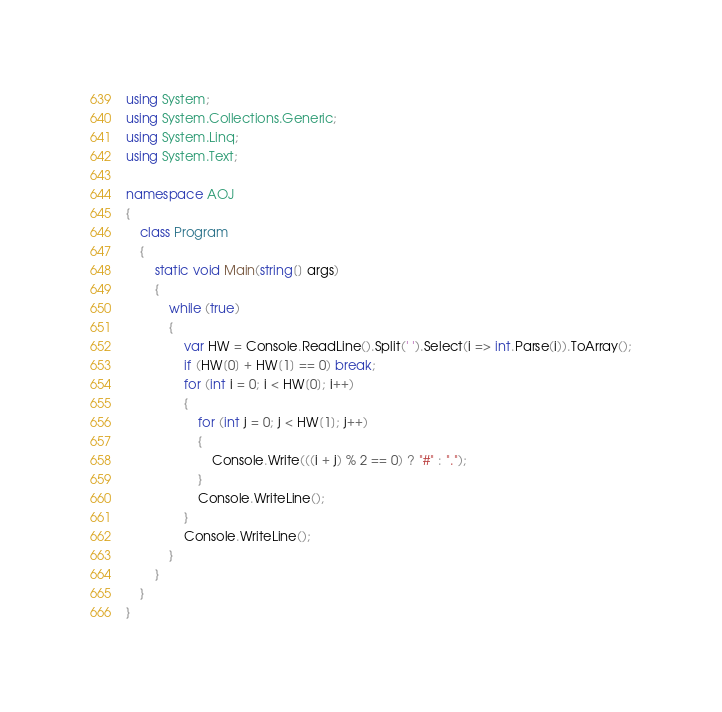Convert code to text. <code><loc_0><loc_0><loc_500><loc_500><_C#_>using System;
using System.Collections.Generic;
using System.Linq;
using System.Text;

namespace AOJ
{
	class Program
	{
		static void Main(string[] args)
		{
			while (true)
			{
				var HW = Console.ReadLine().Split(' ').Select(i => int.Parse(i)).ToArray();
				if (HW[0] + HW[1] == 0) break;
				for (int i = 0; i < HW[0]; i++)
				{
					for (int j = 0; j < HW[1]; j++)
					{
						Console.Write(((i + j) % 2 == 0) ? "#" : ".");
					}
					Console.WriteLine();
				}
				Console.WriteLine();
			}
		}
	}
}</code> 